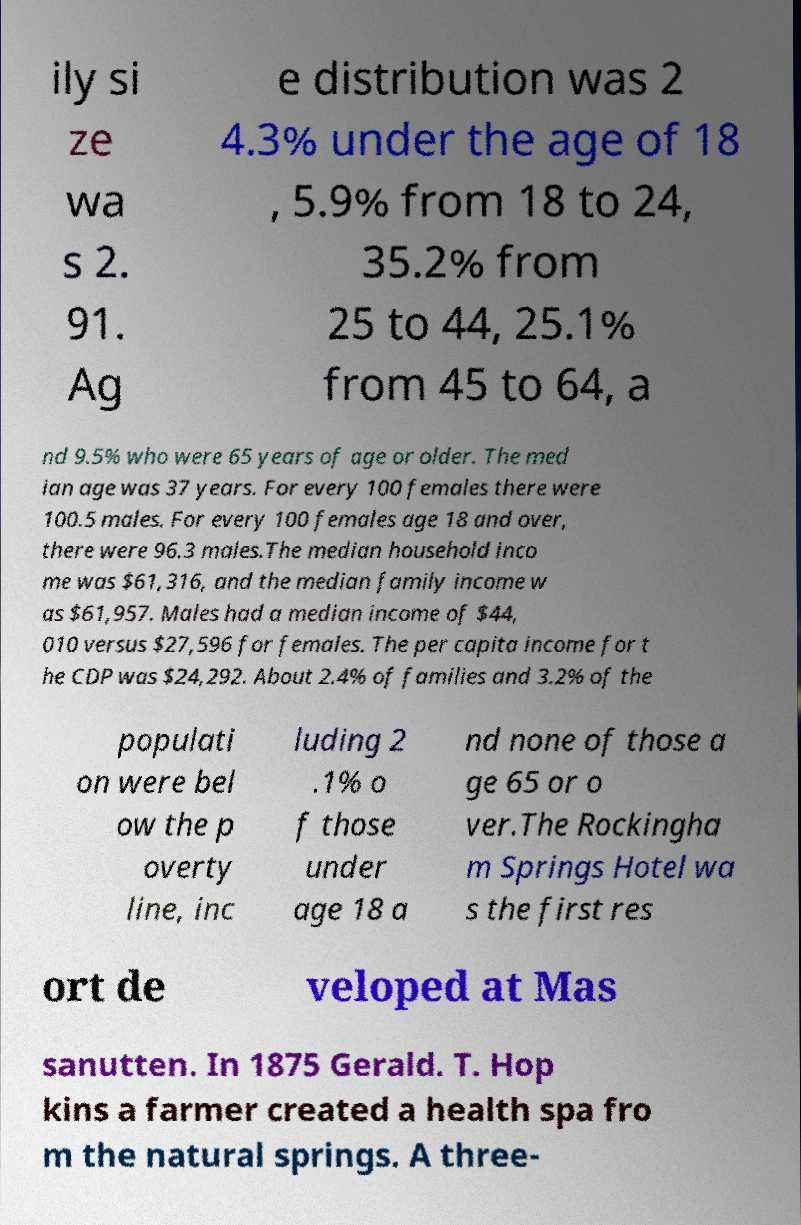Please read and relay the text visible in this image. What does it say? ily si ze wa s 2. 91. Ag e distribution was 2 4.3% under the age of 18 , 5.9% from 18 to 24, 35.2% from 25 to 44, 25.1% from 45 to 64, a nd 9.5% who were 65 years of age or older. The med ian age was 37 years. For every 100 females there were 100.5 males. For every 100 females age 18 and over, there were 96.3 males.The median household inco me was $61,316, and the median family income w as $61,957. Males had a median income of $44, 010 versus $27,596 for females. The per capita income for t he CDP was $24,292. About 2.4% of families and 3.2% of the populati on were bel ow the p overty line, inc luding 2 .1% o f those under age 18 a nd none of those a ge 65 or o ver.The Rockingha m Springs Hotel wa s the first res ort de veloped at Mas sanutten. In 1875 Gerald. T. Hop kins a farmer created a health spa fro m the natural springs. A three- 